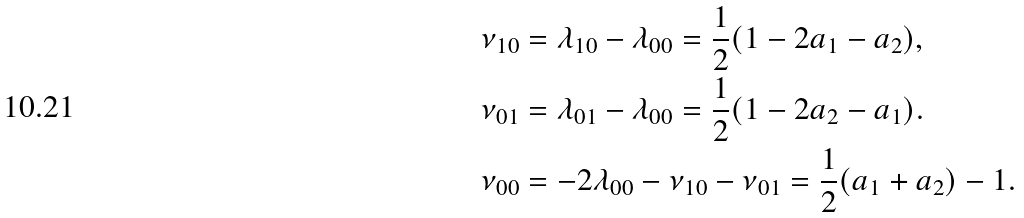<formula> <loc_0><loc_0><loc_500><loc_500>\nu _ { 1 0 } & = \lambda _ { 1 0 } - \lambda _ { 0 0 } = \frac { 1 } { 2 } ( 1 - 2 a _ { 1 } - a _ { 2 } ) , \\ \nu _ { 0 1 } & = \lambda _ { 0 1 } - \lambda _ { 0 0 } = \frac { 1 } { 2 } ( 1 - 2 a _ { 2 } - a _ { 1 } ) . \\ \nu _ { 0 0 } & = - 2 \lambda _ { 0 0 } - \nu _ { 1 0 } - \nu _ { 0 1 } = \frac { 1 } { 2 } ( a _ { 1 } + a _ { 2 } ) - 1 .</formula> 